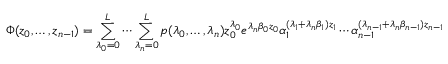Convert formula to latex. <formula><loc_0><loc_0><loc_500><loc_500>\Phi ( z _ { 0 } , \dots , z _ { n - 1 } ) = \sum _ { \lambda _ { 0 } = 0 } ^ { L } \cdots \sum _ { \lambda _ { n } = 0 } ^ { L } p ( \lambda _ { 0 } , \dots , \lambda _ { n } ) z _ { 0 } ^ { \lambda _ { 0 } } e ^ { \lambda _ { n } \beta _ { 0 } z _ { 0 } } \alpha _ { 1 } ^ { ( \lambda _ { 1 } + \lambda _ { n } \beta _ { 1 } ) z _ { 1 } } \cdots \alpha _ { n - 1 } ^ { ( \lambda _ { n - 1 } + \lambda _ { n } \beta _ { n - 1 } ) z _ { n - 1 } }</formula> 